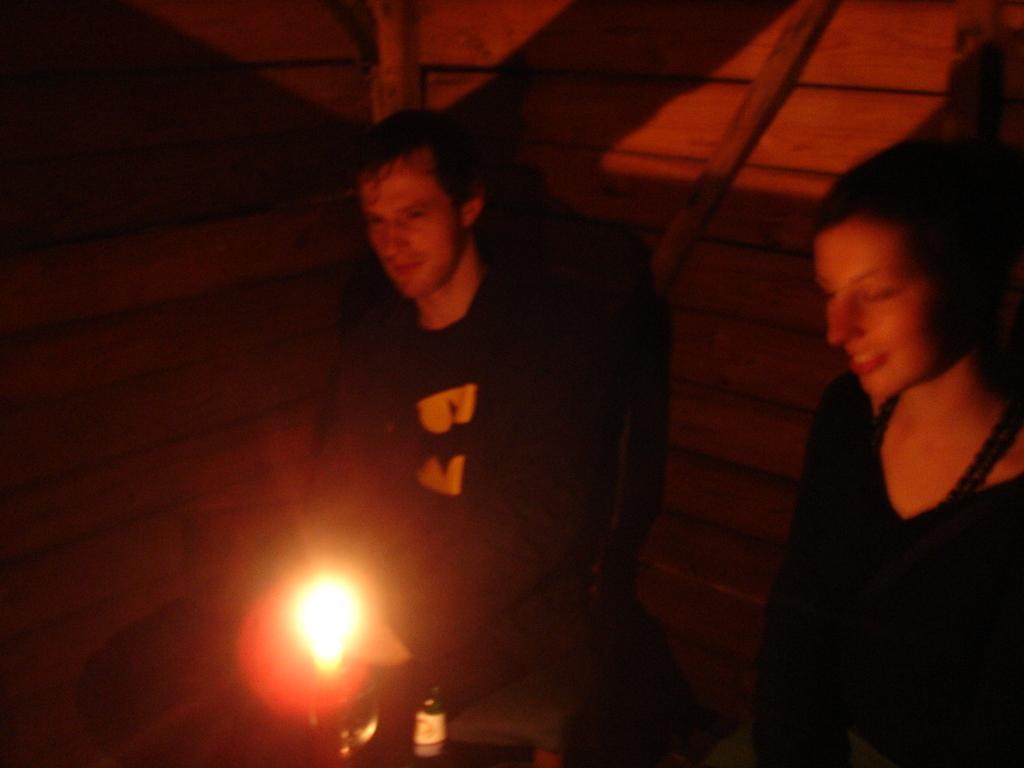In one or two sentences, can you explain what this image depicts? In this picture we can see there are two persons. In front of the people, there is light and an object. Behind the people, it looks like a wooden wall. 